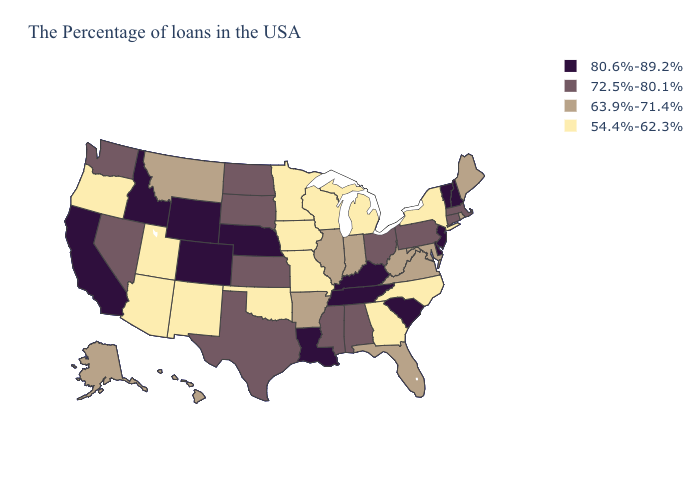What is the highest value in states that border Utah?
Keep it brief. 80.6%-89.2%. Name the states that have a value in the range 80.6%-89.2%?
Write a very short answer. New Hampshire, Vermont, New Jersey, Delaware, South Carolina, Kentucky, Tennessee, Louisiana, Nebraska, Wyoming, Colorado, Idaho, California. Name the states that have a value in the range 72.5%-80.1%?
Keep it brief. Massachusetts, Connecticut, Pennsylvania, Ohio, Alabama, Mississippi, Kansas, Texas, South Dakota, North Dakota, Nevada, Washington. What is the value of Tennessee?
Keep it brief. 80.6%-89.2%. What is the value of Nevada?
Be succinct. 72.5%-80.1%. Does Oregon have the lowest value in the USA?
Concise answer only. Yes. Does the first symbol in the legend represent the smallest category?
Write a very short answer. No. Does Illinois have the highest value in the MidWest?
Concise answer only. No. Which states have the lowest value in the USA?
Concise answer only. New York, North Carolina, Georgia, Michigan, Wisconsin, Missouri, Minnesota, Iowa, Oklahoma, New Mexico, Utah, Arizona, Oregon. Does the first symbol in the legend represent the smallest category?
Concise answer only. No. What is the lowest value in the USA?
Be succinct. 54.4%-62.3%. Does New Jersey have the highest value in the USA?
Give a very brief answer. Yes. Among the states that border Delaware , which have the lowest value?
Quick response, please. Maryland. 